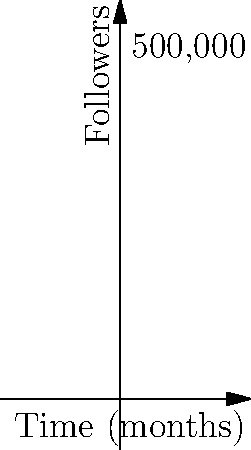As a Nigerian social media influencer supporting the government, your follower count is growing rapidly. The graph shows your follower growth over time, represented by the function $f(t) = \frac{500000}{1+e^{-0.5(t-5)}}$, where $t$ is time in months. At what point in time is the rate of follower growth the highest? To find the point of highest growth rate, we need to determine when the derivative of the function is at its maximum.

1. First, let's calculate the derivative of $f(t)$:
   $f'(t) = \frac{500000 \cdot 0.5e^{-0.5(t-5)}}{(1+e^{-0.5(t-5)})^2}$

2. The maximum of $f'(t)$ occurs when the second derivative $f''(t) = 0$.
   However, solving this equation analytically is complex.

3. We can observe that the logistic function is symmetric around its inflection point.
   For a logistic function of the form $\frac{L}{1+e^{-k(t-t_0)}}$, the inflection point occurs at $t = t_0$.

4. In our case, $L = 500000$, $k = 0.5$, and $t_0 = 5$.

5. Therefore, the point of highest growth rate (inflection point) is at $t = 5$ months.

This aligns with the graph, where we can see the steepest slope occurs around the middle of the curve.
Answer: 5 months 